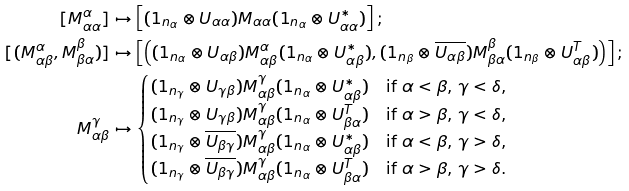Convert formula to latex. <formula><loc_0><loc_0><loc_500><loc_500>[ M _ { \alpha \alpha } ^ { \alpha } ] & \mapsto \left [ ( 1 _ { n _ { \alpha } } \otimes U _ { \alpha \alpha } ) M _ { \alpha \alpha } ( 1 _ { n _ { \alpha } } \otimes U _ { \alpha \alpha } ^ { * } ) \right ] ; \\ [ ( M _ { \alpha \beta } ^ { \alpha } , M _ { \beta \alpha } ^ { \beta } ) ] & \mapsto \left [ \left ( ( 1 _ { n _ { \alpha } } \otimes U _ { \alpha \beta } ) M _ { \alpha \beta } ^ { \alpha } ( 1 _ { n _ { \alpha } } \otimes U _ { \alpha \beta } ^ { * } ) , ( 1 _ { n _ { \beta } } \otimes \overline { U _ { \alpha \beta } } ) M _ { \beta \alpha } ^ { \beta } ( 1 _ { n _ { \beta } } \otimes U _ { \alpha \beta } ^ { T } ) \right ) \right ] ; \\ M _ { \alpha \beta } ^ { \gamma } & \mapsto \begin{cases} ( 1 _ { n _ { \gamma } } \otimes U _ { \gamma \beta } ) M _ { \alpha \beta } ^ { \gamma } ( 1 _ { n _ { \alpha } } \otimes U _ { \alpha \beta } ^ { * } ) & \text {if $\alpha < \beta$, $\gamma < \delta$,} \\ ( 1 _ { n _ { \gamma } } \otimes U _ { \gamma \beta } ) M _ { \alpha \beta } ^ { \gamma } ( 1 _ { n _ { \alpha } } \otimes U _ { \beta \alpha } ^ { T } ) & \text {if $\alpha > \beta$, $\gamma < \delta$,} \\ ( 1 _ { n _ { \gamma } } \otimes \overline { U _ { \beta \gamma } } ) M _ { \alpha \beta } ^ { \gamma } ( 1 _ { n _ { \alpha } } \otimes U _ { \alpha \beta } ^ { * } ) & \text {if $\alpha < \beta$, $\gamma > \delta$,} \\ ( 1 _ { n _ { \gamma } } \otimes \overline { U _ { \beta \gamma } } ) M _ { \alpha \beta } ^ { \gamma } ( 1 _ { n _ { \alpha } } \otimes U _ { \beta \alpha } ^ { T } ) & \text {if $\alpha > \beta$, $\gamma > \delta$.} \end{cases}</formula> 